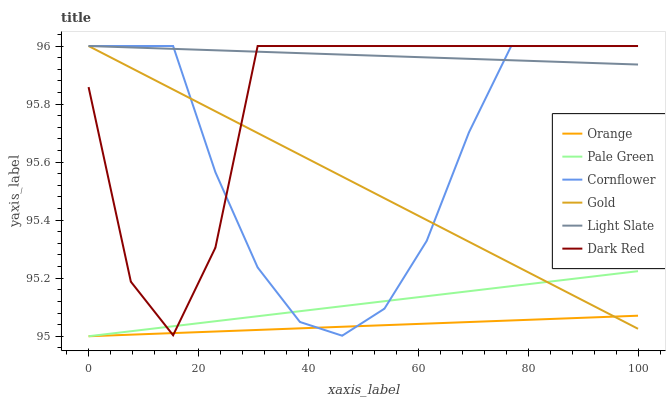Does Orange have the minimum area under the curve?
Answer yes or no. Yes. Does Light Slate have the maximum area under the curve?
Answer yes or no. Yes. Does Gold have the minimum area under the curve?
Answer yes or no. No. Does Gold have the maximum area under the curve?
Answer yes or no. No. Is Gold the smoothest?
Answer yes or no. Yes. Is Dark Red the roughest?
Answer yes or no. Yes. Is Light Slate the smoothest?
Answer yes or no. No. Is Light Slate the roughest?
Answer yes or no. No. Does Pale Green have the lowest value?
Answer yes or no. Yes. Does Gold have the lowest value?
Answer yes or no. No. Does Dark Red have the highest value?
Answer yes or no. Yes. Does Pale Green have the highest value?
Answer yes or no. No. Is Orange less than Light Slate?
Answer yes or no. Yes. Is Light Slate greater than Orange?
Answer yes or no. Yes. Does Light Slate intersect Gold?
Answer yes or no. Yes. Is Light Slate less than Gold?
Answer yes or no. No. Is Light Slate greater than Gold?
Answer yes or no. No. Does Orange intersect Light Slate?
Answer yes or no. No. 